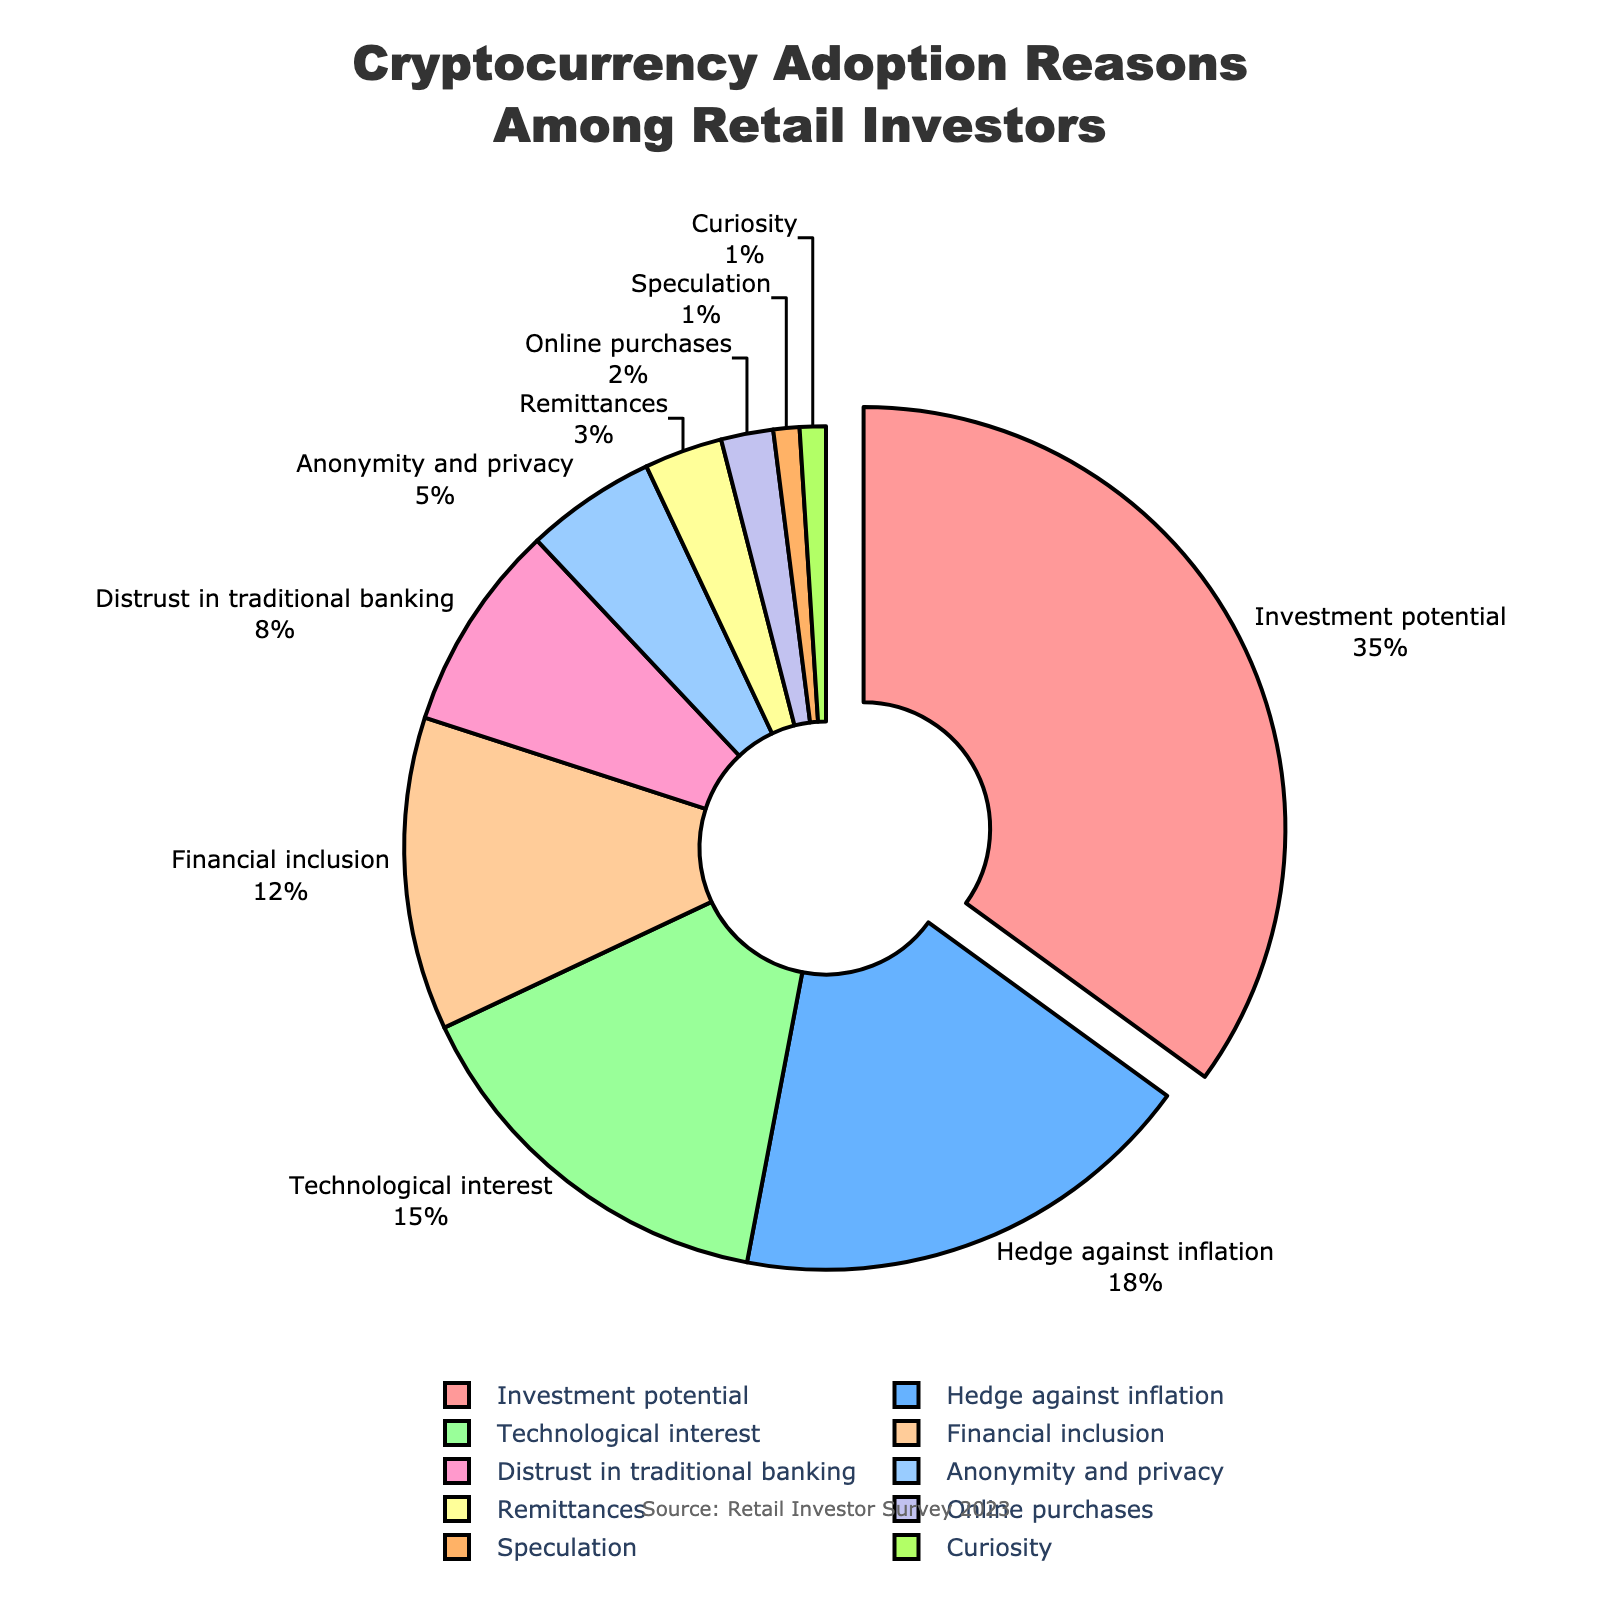Which reason for cryptocurrency adoption has the highest percentage? The pie chart shows that "Investment potential" occupies the largest segment.
Answer: Investment potential What percentage of respondents chose "Hedge against inflation"? Referring to the pie chart, the slice for "Hedge against inflation" shows 18%.
Answer: 18% How do the combined percentages for "Technological interest" and "Financial inclusion" compare to "Investment potential"? The percentages for "Technological interest" (15%) and "Financial inclusion" (12%) add up to 27%. "Investment potential" is 35%. So, the combined percentage is less than "Investment potential".
Answer: Less Which reason has the smallest percentage, and what is that percentage? The pie chart indicates that "Speculation" and "Curiosity" each have a small slice labeled 1%.
Answer: Speculation and Curiosity, 1% How does the percentage for "Anonymity and privacy" compare to "Remittances"? The pie chart shows "Anonymity and privacy" at 5% and "Remittances" at 3%, so "Anonymity and privacy" is greater.
Answer: Greater What is the total percentage accounted for by reasons related to distrust in traditional systems, specifically "Distrust in traditional banking" and "Anonymity and privacy"? Adding "Distrust in traditional banking" (8%) and "Anonymity and privacy" (5%) gives a total of 13%.
Answer: 13% If you combine the percentages for "Financial inclusion" and "Distrust in traditional banking," how does that total compare to "Hedge against inflation"? "Financial inclusion" is 12% and "Distrust in traditional banking" is 8%, summing to 20%, which is greater than "Hedge against inflation" at 18%.
Answer: Greater What percentages are represented by the segments pulled out of the pie chart, and why are they pulled out? Only the "Investment potential" segment is pulled out, and it represents 35% of the total, likely pulled out to highlight that it's the largest segment.
Answer: 35% Which two reasons have the closest percentages, and what are those percentages? The pie chart shows "Remittances" and "Online purchases" at 3% and 2% respectively, which are the closest percentages.
Answer: Remittances (3%) and Online purchases (2%) What is the total percentage for reasons not related to financial motives (excluding "Investment potential" and "Hedge against inflation")? Adding "Technological interest" (15%), "Financial inclusion" (12%), "Distrust in traditional banking" (8%), "Anonymity and privacy" (5%), "Remittances" (3%), "Online purchases" (2%), "Speculation" (1%), and "Curiosity" (1%) results in 47%.
Answer: 47% 